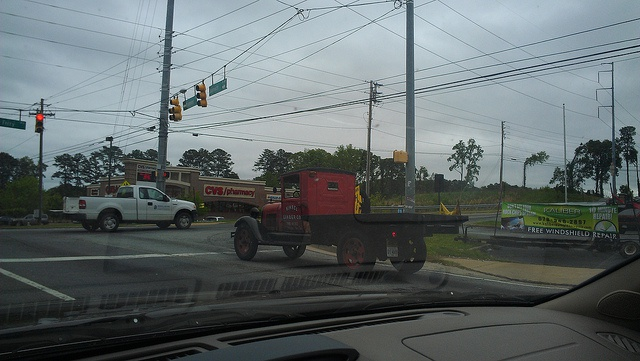Describe the objects in this image and their specific colors. I can see truck in gray, black, and maroon tones, truck in gray, black, and purple tones, car in gray, black, and purple tones, traffic light in gray, maroon, and black tones, and traffic light in gray, maroon, black, and darkgray tones in this image. 